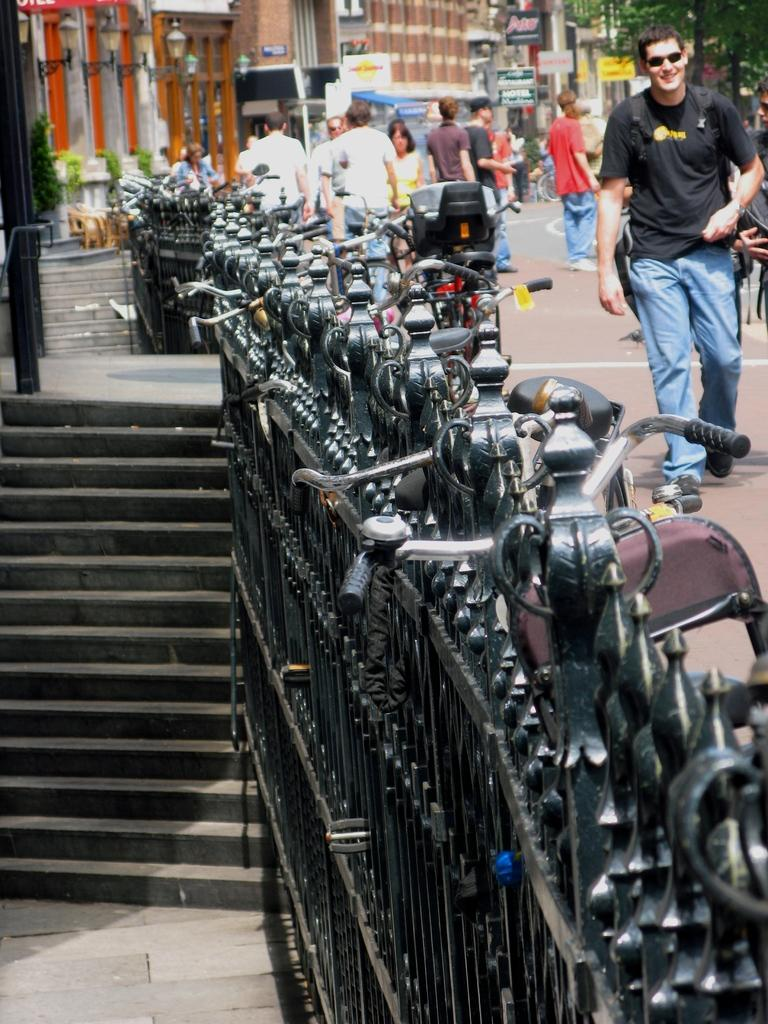What types of objects can be seen in the image? There are vehicles, people, stairs, plants, trees, buildings, boards, poles, lights, and a fence in the image. Can you describe the people in the image? The image shows people, but their specific actions or characteristics are not mentioned in the provided facts. What type of structures are present in the image? There are stairs, buildings, and a fence in the image. What natural elements can be seen in the image? There are plants and trees in the image. What type of lighting is present in the image? There are lights in the image. How many sheep are visible in the image? There are no sheep present in the image. What type of ring can be seen on the person's finger in the image? There is no mention of a ring or any person's finger in the provided facts. --- 